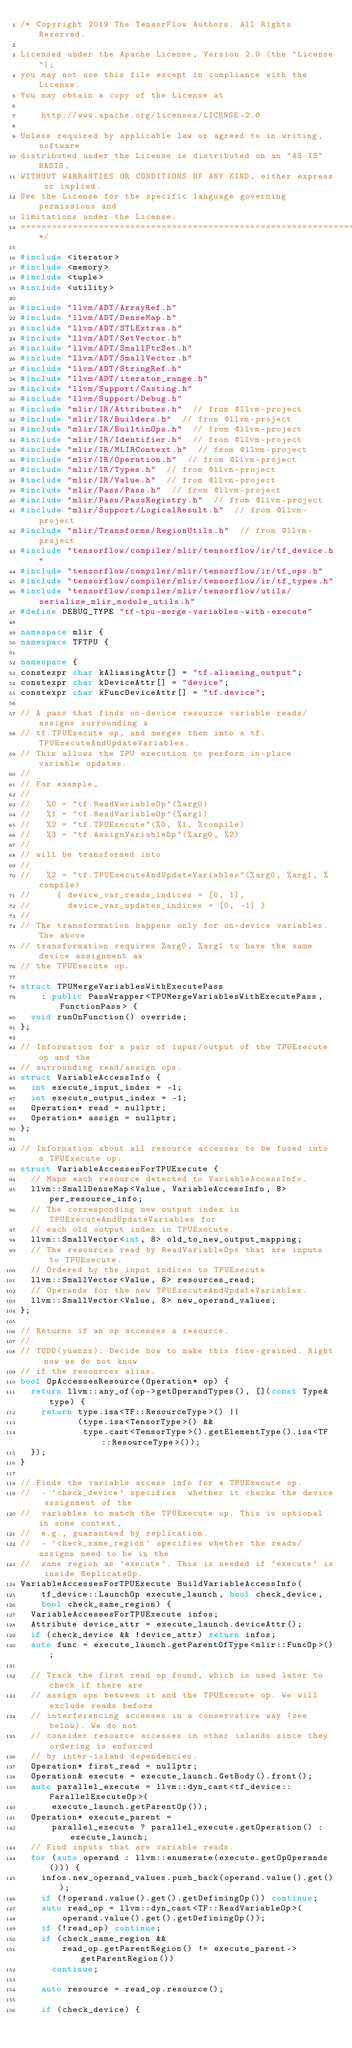<code> <loc_0><loc_0><loc_500><loc_500><_C++_>/* Copyright 2019 The TensorFlow Authors. All Rights Reserved.

Licensed under the Apache License, Version 2.0 (the "License");
you may not use this file except in compliance with the License.
You may obtain a copy of the License at

    http://www.apache.org/licenses/LICENSE-2.0

Unless required by applicable law or agreed to in writing, software
distributed under the License is distributed on an "AS IS" BASIS,
WITHOUT WARRANTIES OR CONDITIONS OF ANY KIND, either express or implied.
See the License for the specific language governing permissions and
limitations under the License.
==============================================================================*/

#include <iterator>
#include <memory>
#include <tuple>
#include <utility>

#include "llvm/ADT/ArrayRef.h"
#include "llvm/ADT/DenseMap.h"
#include "llvm/ADT/STLExtras.h"
#include "llvm/ADT/SetVector.h"
#include "llvm/ADT/SmallPtrSet.h"
#include "llvm/ADT/SmallVector.h"
#include "llvm/ADT/StringRef.h"
#include "llvm/ADT/iterator_range.h"
#include "llvm/Support/Casting.h"
#include "llvm/Support/Debug.h"
#include "mlir/IR/Attributes.h"  // from @llvm-project
#include "mlir/IR/Builders.h"  // from @llvm-project
#include "mlir/IR/BuiltinOps.h"  // from @llvm-project
#include "mlir/IR/Identifier.h"  // from @llvm-project
#include "mlir/IR/MLIRContext.h"  // from @llvm-project
#include "mlir/IR/Operation.h"  // from @llvm-project
#include "mlir/IR/Types.h"  // from @llvm-project
#include "mlir/IR/Value.h"  // from @llvm-project
#include "mlir/Pass/Pass.h"  // from @llvm-project
#include "mlir/Pass/PassRegistry.h"  // from @llvm-project
#include "mlir/Support/LogicalResult.h"  // from @llvm-project
#include "mlir/Transforms/RegionUtils.h"  // from @llvm-project
#include "tensorflow/compiler/mlir/tensorflow/ir/tf_device.h"
#include "tensorflow/compiler/mlir/tensorflow/ir/tf_ops.h"
#include "tensorflow/compiler/mlir/tensorflow/ir/tf_types.h"
#include "tensorflow/compiler/mlir/tensorflow/utils/serialize_mlir_module_utils.h"
#define DEBUG_TYPE "tf-tpu-merge-variables-with-execute"

namespace mlir {
namespace TFTPU {

namespace {
constexpr char kAliasingAttr[] = "tf.aliasing_output";
constexpr char kDeviceAttr[] = "device";
constexpr char kFuncDeviceAttr[] = "tf.device";

// A pass that finds on-device resource variable reads/assigns surrounding a
// tf.TPUExecute op, and merges them into a tf.TPUExecuteAndUpdateVariables.
// This allows the TPU execution to perform in-place variable updates.
//
// For example,
//
//   %0 = "tf.ReadVariableOp"(%arg0)
//   %1 = "tf.ReadVariableOp"(%arg1)
//   %2 = "tf.TPUExecute"(%0, %1, %compile)
//   %3 = "tf.AssignVariableOp"(%arg0, %2)
//
// will be transformed into
//
//   %2 = "tf.TPUExecuteAndUpdateVariables"(%arg0, %arg1, %compile)
//     { device_var_reads_indices = [0, 1],
//       device_var_updates_indices = [0, -1] }
//
// The transformation happens only for on-device variables. The above
// transformation requires %arg0, %arg1 to have the same device assignment as
// the TPUExecute op.

struct TPUMergeVariablesWithExecutePass
    : public PassWrapper<TPUMergeVariablesWithExecutePass, FunctionPass> {
  void runOnFunction() override;
};

// Information for a pair of input/output of the TPUExecute op and the
// surrounding read/assign ops.
struct VariableAccessInfo {
  int execute_input_index = -1;
  int execute_output_index = -1;
  Operation* read = nullptr;
  Operation* assign = nullptr;
};

// Information about all resource accesses to be fused into a TPUExecute op.
struct VariableAccessesForTPUExecute {
  // Maps each resource detected to VariableAccessInfo.
  llvm::SmallDenseMap<Value, VariableAccessInfo, 8> per_resource_info;
  // The corresponding new output index in TPUExecuteAndUpdateVariables for
  // each old output index in TPUExecute.
  llvm::SmallVector<int, 8> old_to_new_output_mapping;
  // The resources read by ReadVariableOps that are inputs to TPUExecute.
  // Ordered by the input indices to TPUExecute
  llvm::SmallVector<Value, 8> resources_read;
  // Operands for the new TPUExecuteAndUpdateVariables.
  llvm::SmallVector<Value, 8> new_operand_values;
};

// Returns if an op accesses a resource.
//
// TODO(yuanzx): Decide how to make this fine-grained. Right now we do not know
// if the resources alias.
bool OpAccessesResource(Operation* op) {
  return llvm::any_of(op->getOperandTypes(), [](const Type& type) {
    return type.isa<TF::ResourceType>() ||
           (type.isa<TensorType>() &&
            type.cast<TensorType>().getElementType().isa<TF::ResourceType>());
  });
}

// Finds the variable access info for a TPUExecute op.
//  - `check_device` specifies  whether it checks the device assignment of the
//  variables to match the TPUExecute op. This is optional in some context,
//  e.g., guaranteed by replication.
//  - `check_same_region` specifies whether the reads/assigns need to be in the
//  same region as `execute`. This is needed if `execute` is inside ReplicateOp.
VariableAccessesForTPUExecute BuildVariableAccessInfo(
    tf_device::LaunchOp execute_launch, bool check_device,
    bool check_same_region) {
  VariableAccessesForTPUExecute infos;
  Attribute device_attr = execute_launch.deviceAttr();
  if (check_device && !device_attr) return infos;
  auto func = execute_launch.getParentOfType<mlir::FuncOp>();

  // Track the first read op found, which is used later to check if there are
  // assign ops between it and the TPUExecute op. We will exclude reads before
  // interferencing accesses in a conservative way (see below). We do not
  // consider resource accesses in other islands since they ordering is enforced
  // by inter-island dependencies.
  Operation* first_read = nullptr;
  Operation& execute = execute_launch.GetBody().front();
  auto parallel_execute = llvm::dyn_cast<tf_device::ParallelExecuteOp>(
      execute_launch.getParentOp());
  Operation* execute_parent =
      parallel_execute ? parallel_execute.getOperation() : execute_launch;
  // Find inputs that are variable reads.
  for (auto operand : llvm::enumerate(execute.getOpOperands())) {
    infos.new_operand_values.push_back(operand.value().get());
    if (!operand.value().get().getDefiningOp()) continue;
    auto read_op = llvm::dyn_cast<TF::ReadVariableOp>(
        operand.value().get().getDefiningOp());
    if (!read_op) continue;
    if (check_same_region &&
        read_op.getParentRegion() != execute_parent->getParentRegion())
      continue;

    auto resource = read_op.resource();

    if (check_device) {</code> 